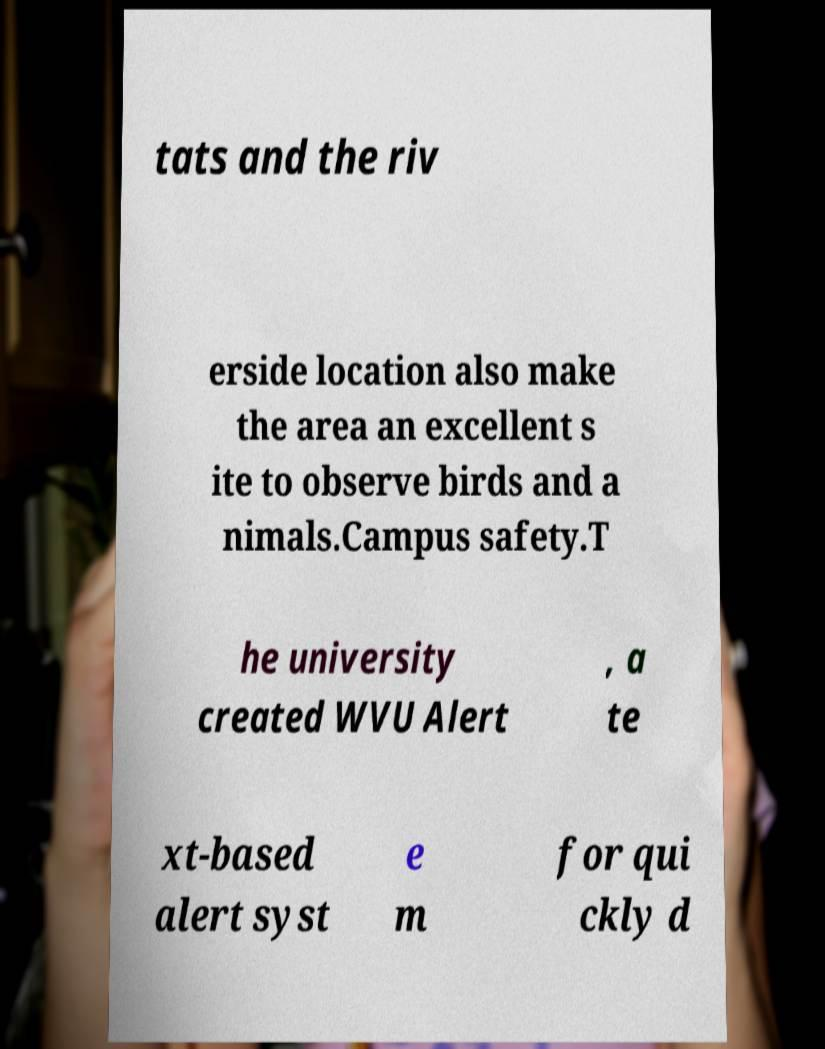Could you extract and type out the text from this image? tats and the riv erside location also make the area an excellent s ite to observe birds and a nimals.Campus safety.T he university created WVU Alert , a te xt-based alert syst e m for qui ckly d 